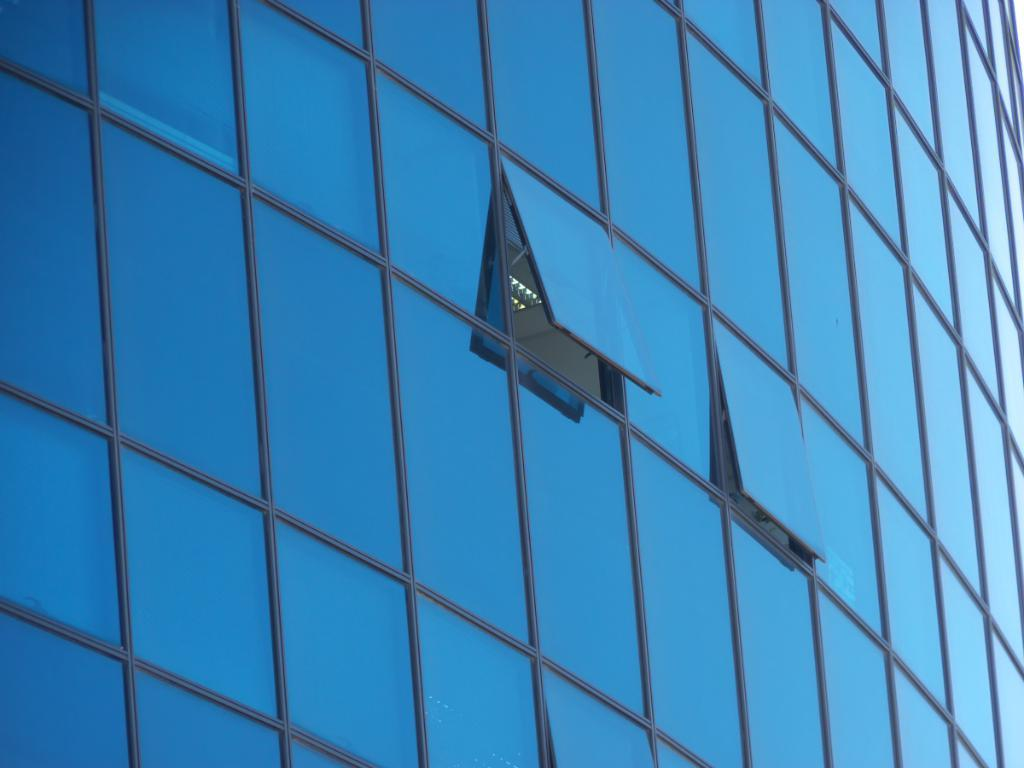What type of structure is in the image? There is a building in the image. What can be observed about the windows of the building? The building has blue colored glass windows, and two of them are partially opened. Can you see any activity inside the building through the windows? Lights are visible through one of the opened windows. What type of berry can be seen growing on the building in the image? There are no berries present on the building in the image. How does the sleet affect the building's appearance in the image? There is no mention of sleet in the image, so its effect on the building's appearance cannot be determined. 